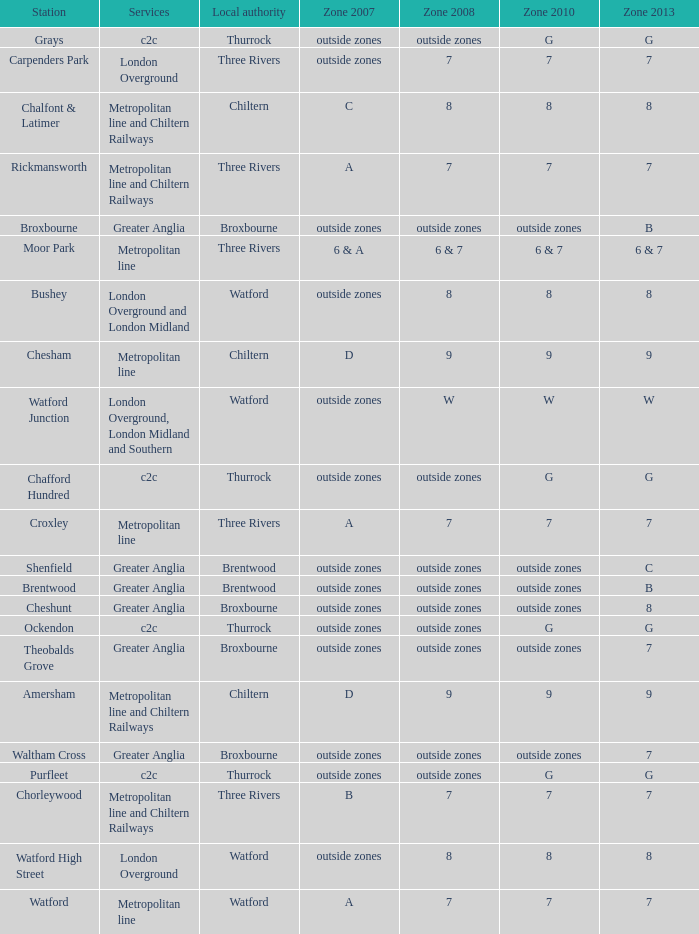Which Services have a Local authority of chiltern, and a Zone 2010 of 9? Metropolitan line and Chiltern Railways, Metropolitan line. 